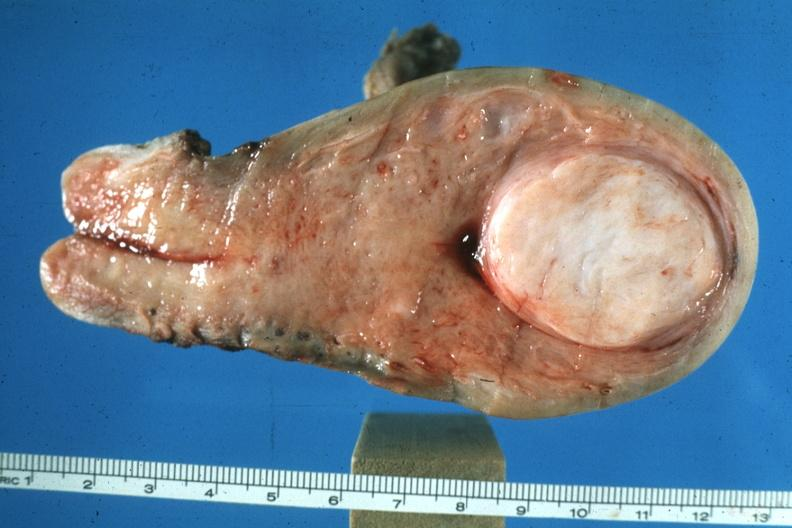what does this image show?
Answer the question using a single word or phrase. Excellent example of rather large submucous myoma 